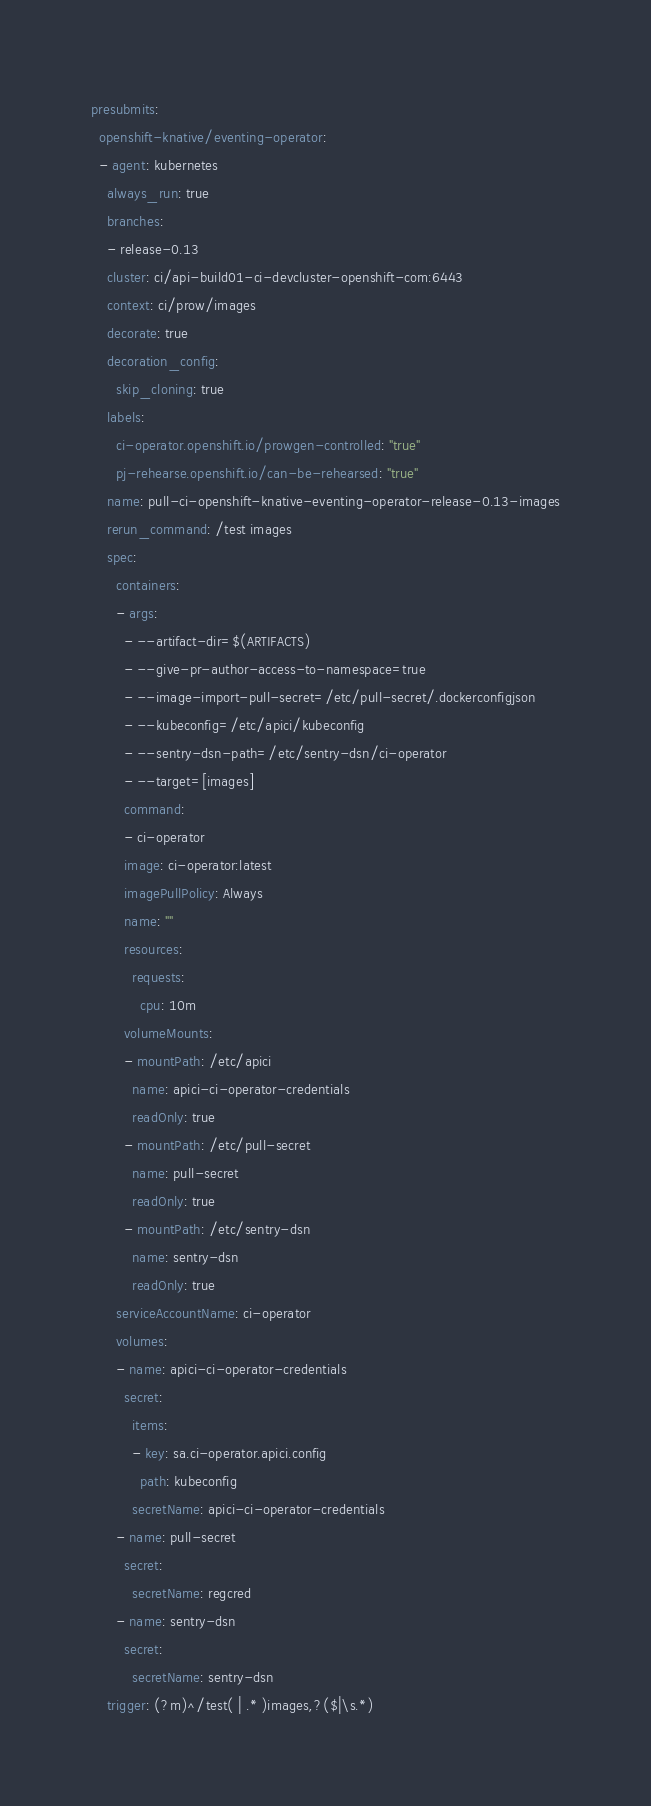Convert code to text. <code><loc_0><loc_0><loc_500><loc_500><_YAML_>presubmits:
  openshift-knative/eventing-operator:
  - agent: kubernetes
    always_run: true
    branches:
    - release-0.13
    cluster: ci/api-build01-ci-devcluster-openshift-com:6443
    context: ci/prow/images
    decorate: true
    decoration_config:
      skip_cloning: true
    labels:
      ci-operator.openshift.io/prowgen-controlled: "true"
      pj-rehearse.openshift.io/can-be-rehearsed: "true"
    name: pull-ci-openshift-knative-eventing-operator-release-0.13-images
    rerun_command: /test images
    spec:
      containers:
      - args:
        - --artifact-dir=$(ARTIFACTS)
        - --give-pr-author-access-to-namespace=true
        - --image-import-pull-secret=/etc/pull-secret/.dockerconfigjson
        - --kubeconfig=/etc/apici/kubeconfig
        - --sentry-dsn-path=/etc/sentry-dsn/ci-operator
        - --target=[images]
        command:
        - ci-operator
        image: ci-operator:latest
        imagePullPolicy: Always
        name: ""
        resources:
          requests:
            cpu: 10m
        volumeMounts:
        - mountPath: /etc/apici
          name: apici-ci-operator-credentials
          readOnly: true
        - mountPath: /etc/pull-secret
          name: pull-secret
          readOnly: true
        - mountPath: /etc/sentry-dsn
          name: sentry-dsn
          readOnly: true
      serviceAccountName: ci-operator
      volumes:
      - name: apici-ci-operator-credentials
        secret:
          items:
          - key: sa.ci-operator.apici.config
            path: kubeconfig
          secretName: apici-ci-operator-credentials
      - name: pull-secret
        secret:
          secretName: regcred
      - name: sentry-dsn
        secret:
          secretName: sentry-dsn
    trigger: (?m)^/test( | .* )images,?($|\s.*)
</code> 